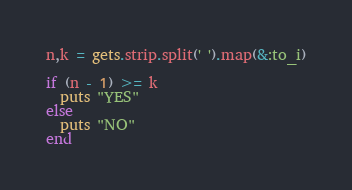Convert code to text. <code><loc_0><loc_0><loc_500><loc_500><_Ruby_>n,k = gets.strip.split(' ').map(&:to_i)

if (n - 1) >= k
  puts "YES"
else
  puts "NO"
end</code> 